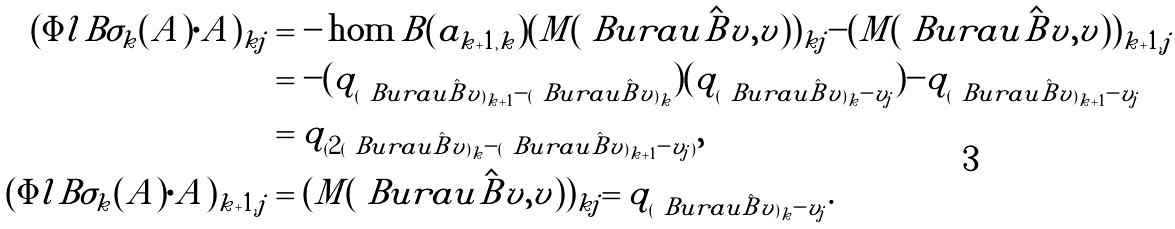Convert formula to latex. <formula><loc_0><loc_0><loc_500><loc_500>( \Phi l { B \sigma _ { k } } ( A ) \cdot A ) _ { k j } & = - \hom { B } ( a _ { k + 1 , k } ) ( M ( \ B u r a u { \hat { B } } v , v ) ) _ { k j } - ( M ( \ B u r a u { \hat { B } } v , v ) ) _ { k + 1 , j } \\ & = - ( q _ { ( \ B u r a u { \hat { B } } v ) _ { k + 1 } - ( \ B u r a u { \hat { B } } v ) _ { k } } ) ( q _ { ( \ B u r a u { \hat { B } } v ) _ { k } - v _ { j } } ) - q _ { ( \ B u r a u { \hat { B } } v ) _ { k + 1 } - v _ { j } } \\ & = q _ { ( 2 ( \ B u r a u { \hat { B } } v ) _ { k } - ( \ B u r a u { \hat { B } } v ) _ { k + 1 } - v _ { j } ) } , \\ ( \Phi l { B \sigma _ { k } } ( A ) \cdot A ) _ { k + 1 , j } & = ( M ( \ B u r a u { \hat { B } } v , v ) ) _ { k j } = q _ { ( \ B u r a u { \hat { B } } v ) _ { k } - v _ { j } } .</formula> 